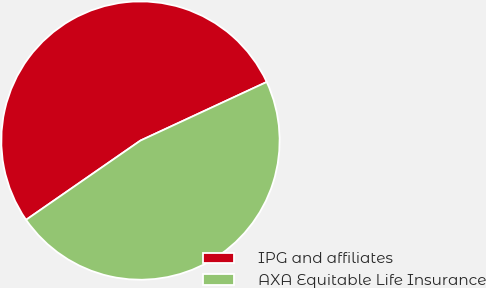<chart> <loc_0><loc_0><loc_500><loc_500><pie_chart><fcel>IPG and affiliates<fcel>AXA Equitable Life Insurance<nl><fcel>52.73%<fcel>47.27%<nl></chart> 